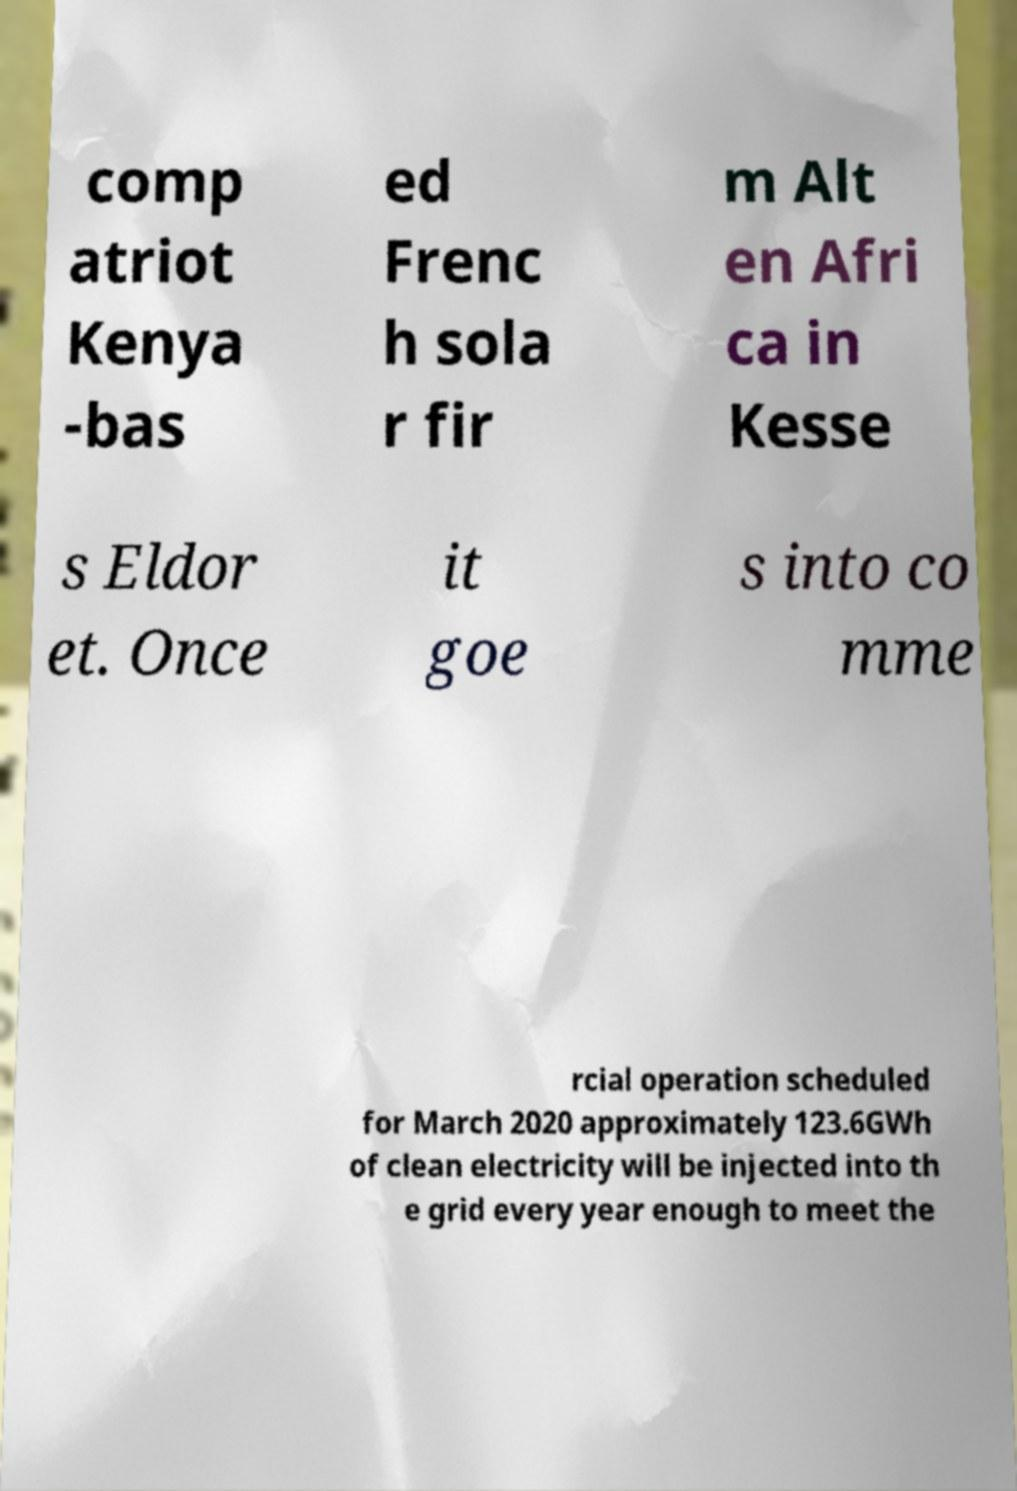I need the written content from this picture converted into text. Can you do that? comp atriot Kenya -bas ed Frenc h sola r fir m Alt en Afri ca in Kesse s Eldor et. Once it goe s into co mme rcial operation scheduled for March 2020 approximately 123.6GWh of clean electricity will be injected into th e grid every year enough to meet the 